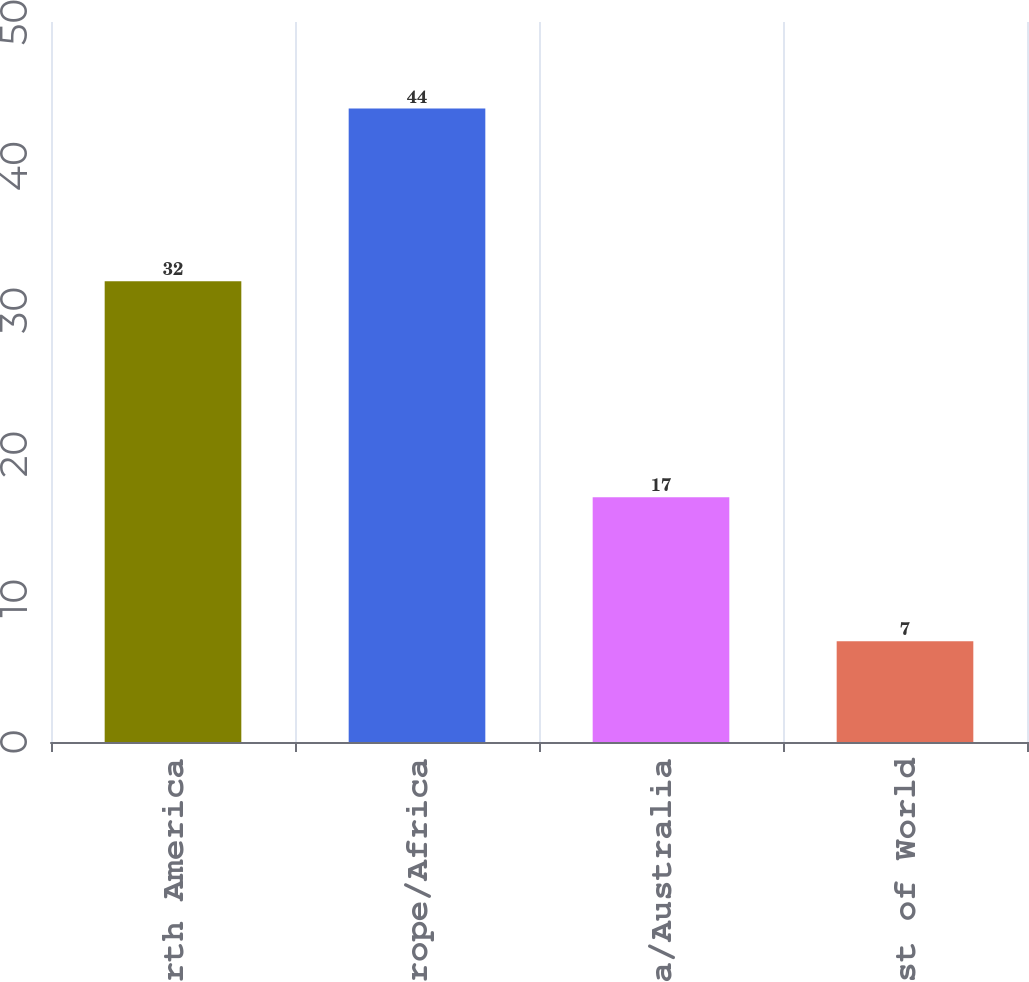<chart> <loc_0><loc_0><loc_500><loc_500><bar_chart><fcel>North America<fcel>Europe/Africa<fcel>Asia/Australia<fcel>Rest of World<nl><fcel>32<fcel>44<fcel>17<fcel>7<nl></chart> 